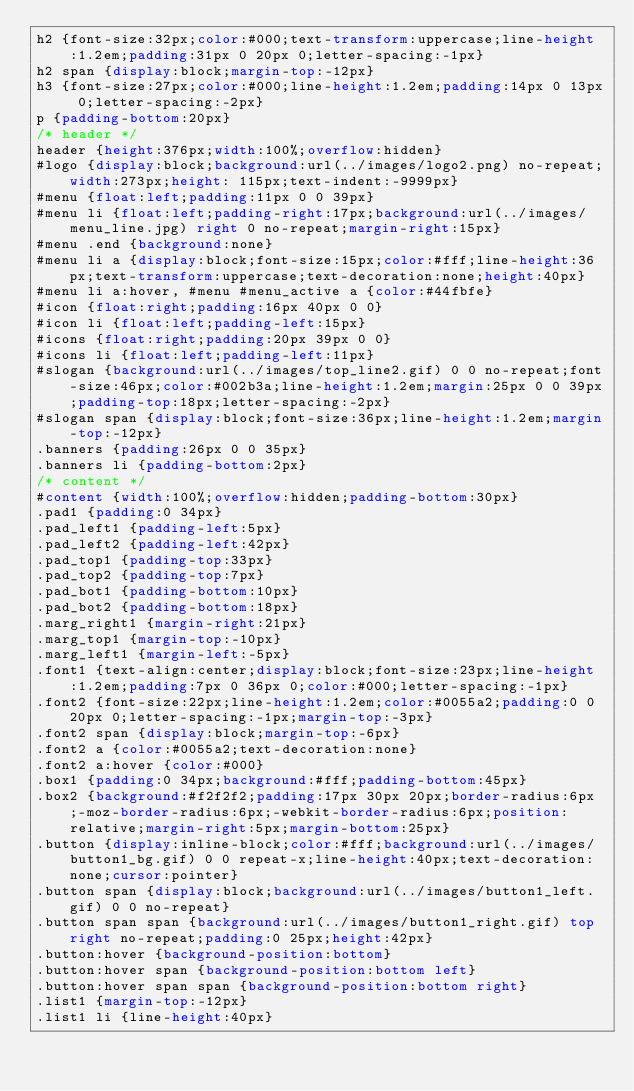<code> <loc_0><loc_0><loc_500><loc_500><_CSS_>h2 {font-size:32px;color:#000;text-transform:uppercase;line-height:1.2em;padding:31px 0 20px 0;letter-spacing:-1px}
h2 span {display:block;margin-top:-12px}
h3 {font-size:27px;color:#000;line-height:1.2em;padding:14px 0 13px 0;letter-spacing:-2px}
p {padding-bottom:20px}
/* header */
header {height:376px;width:100%;overflow:hidden}
#logo {display:block;background:url(../images/logo2.png) no-repeat;width:273px;height: 115px;text-indent:-9999px}
#menu {float:left;padding:11px 0 0 39px}
#menu li {float:left;padding-right:17px;background:url(../images/menu_line.jpg) right 0 no-repeat;margin-right:15px}
#menu .end {background:none}
#menu li a {display:block;font-size:15px;color:#fff;line-height:36px;text-transform:uppercase;text-decoration:none;height:40px}
#menu li a:hover, #menu #menu_active a {color:#44fbfe}
#icon {float:right;padding:16px 40px 0 0}
#icon li {float:left;padding-left:15px}
#icons {float:right;padding:20px 39px 0 0}
#icons li {float:left;padding-left:11px}
#slogan {background:url(../images/top_line2.gif) 0 0 no-repeat;font-size:46px;color:#002b3a;line-height:1.2em;margin:25px 0 0 39px;padding-top:18px;letter-spacing:-2px}
#slogan span {display:block;font-size:36px;line-height:1.2em;margin-top:-12px}
.banners {padding:26px 0 0 35px}
.banners li {padding-bottom:2px}
/* content */
#content {width:100%;overflow:hidden;padding-bottom:30px}
.pad1 {padding:0 34px}
.pad_left1 {padding-left:5px}
.pad_left2 {padding-left:42px}
.pad_top1 {padding-top:33px}
.pad_top2 {padding-top:7px}
.pad_bot1 {padding-bottom:10px}
.pad_bot2 {padding-bottom:18px}
.marg_right1 {margin-right:21px}
.marg_top1 {margin-top:-10px}
.marg_left1 {margin-left:-5px}
.font1 {text-align:center;display:block;font-size:23px;line-height:1.2em;padding:7px 0 36px 0;color:#000;letter-spacing:-1px}
.font2 {font-size:22px;line-height:1.2em;color:#0055a2;padding:0 0 20px 0;letter-spacing:-1px;margin-top:-3px}
.font2 span {display:block;margin-top:-6px}
.font2 a {color:#0055a2;text-decoration:none}
.font2 a:hover {color:#000}
.box1 {padding:0 34px;background:#fff;padding-bottom:45px}
.box2 {background:#f2f2f2;padding:17px 30px 20px;border-radius:6px;-moz-border-radius:6px;-webkit-border-radius:6px;position:relative;margin-right:5px;margin-bottom:25px}
.button {display:inline-block;color:#fff;background:url(../images/button1_bg.gif) 0 0 repeat-x;line-height:40px;text-decoration:none;cursor:pointer}
.button span {display:block;background:url(../images/button1_left.gif) 0 0 no-repeat}
.button span span {background:url(../images/button1_right.gif) top right no-repeat;padding:0 25px;height:42px}
.button:hover {background-position:bottom}
.button:hover span {background-position:bottom left}
.button:hover span span {background-position:bottom right}
.list1 {margin-top:-12px}
.list1 li {line-height:40px}</code> 